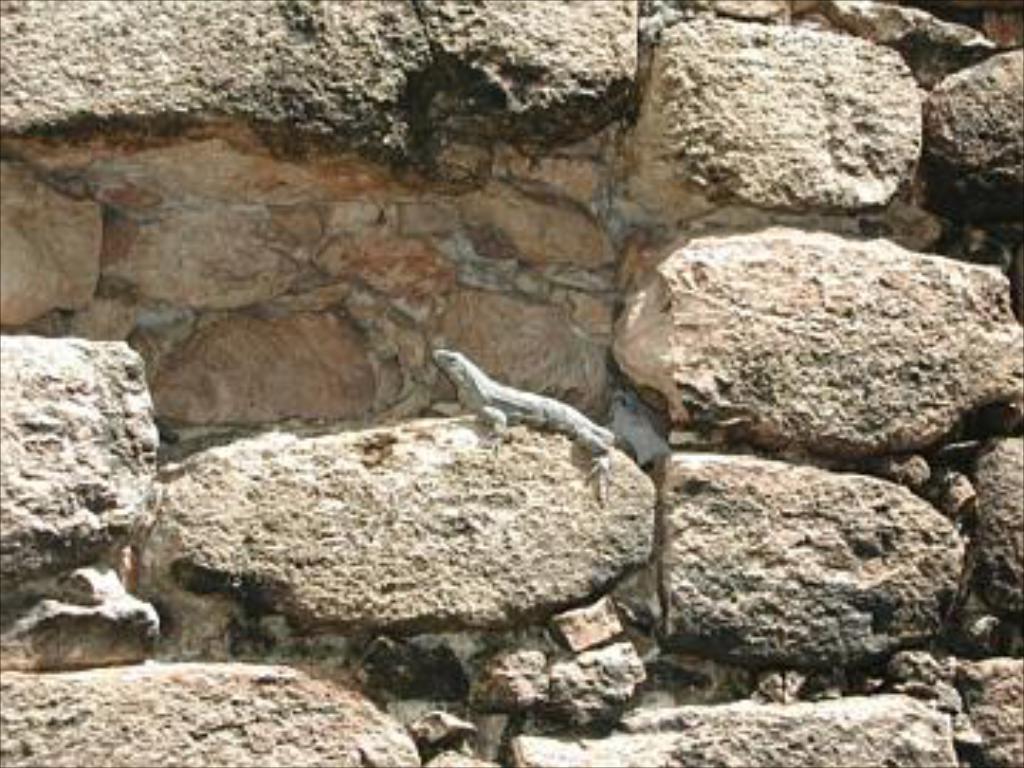Could you give a brief overview of what you see in this image? In the picture there is a wall built with huge stones and there is a lizard on one of the stone. 